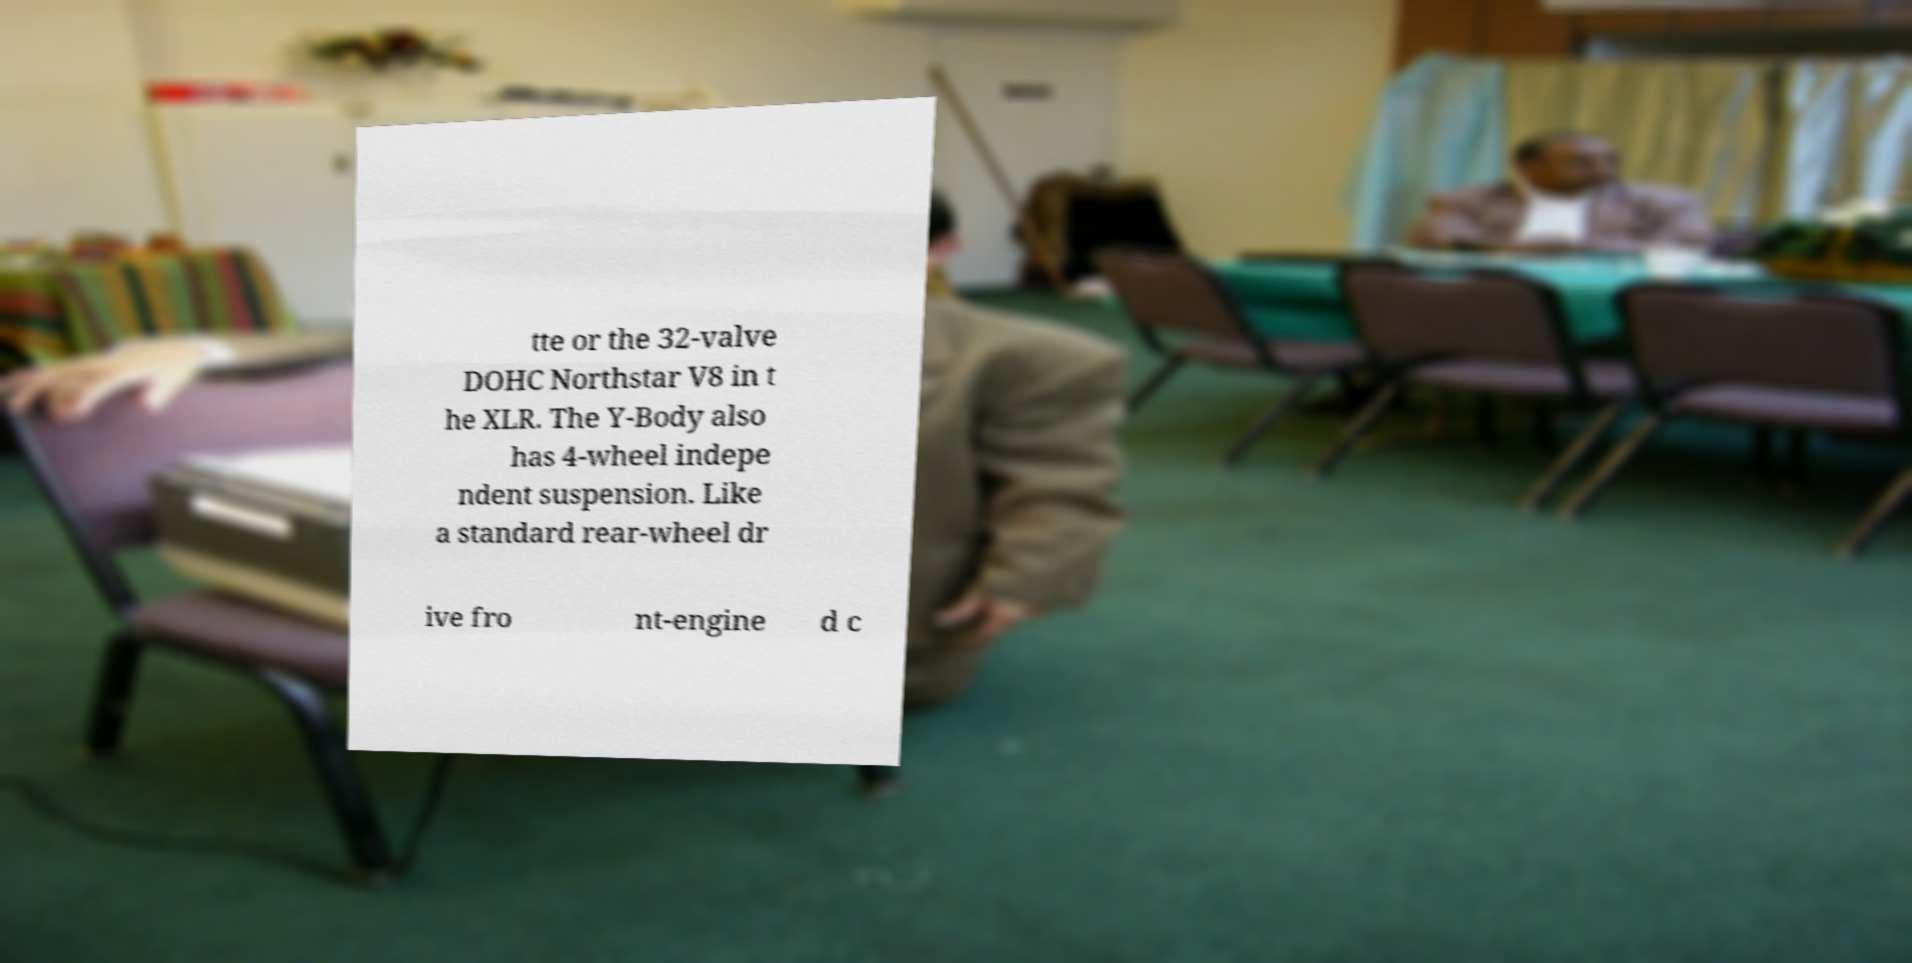Can you accurately transcribe the text from the provided image for me? tte or the 32-valve DOHC Northstar V8 in t he XLR. The Y-Body also has 4-wheel indepe ndent suspension. Like a standard rear-wheel dr ive fro nt-engine d c 